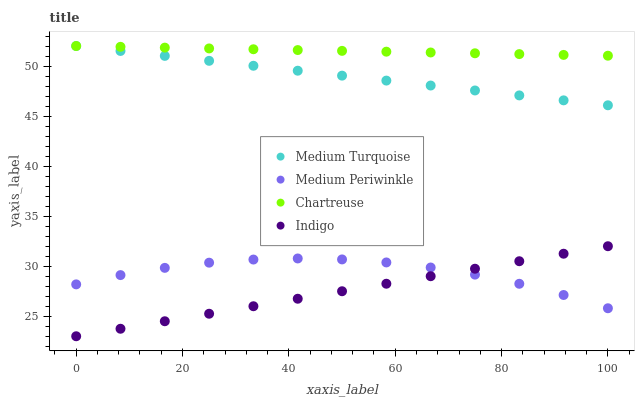Does Indigo have the minimum area under the curve?
Answer yes or no. Yes. Does Chartreuse have the maximum area under the curve?
Answer yes or no. Yes. Does Medium Periwinkle have the minimum area under the curve?
Answer yes or no. No. Does Medium Periwinkle have the maximum area under the curve?
Answer yes or no. No. Is Indigo the smoothest?
Answer yes or no. Yes. Is Medium Periwinkle the roughest?
Answer yes or no. Yes. Is Chartreuse the smoothest?
Answer yes or no. No. Is Chartreuse the roughest?
Answer yes or no. No. Does Indigo have the lowest value?
Answer yes or no. Yes. Does Medium Periwinkle have the lowest value?
Answer yes or no. No. Does Medium Turquoise have the highest value?
Answer yes or no. Yes. Does Medium Periwinkle have the highest value?
Answer yes or no. No. Is Indigo less than Medium Turquoise?
Answer yes or no. Yes. Is Medium Turquoise greater than Medium Periwinkle?
Answer yes or no. Yes. Does Medium Turquoise intersect Chartreuse?
Answer yes or no. Yes. Is Medium Turquoise less than Chartreuse?
Answer yes or no. No. Is Medium Turquoise greater than Chartreuse?
Answer yes or no. No. Does Indigo intersect Medium Turquoise?
Answer yes or no. No. 